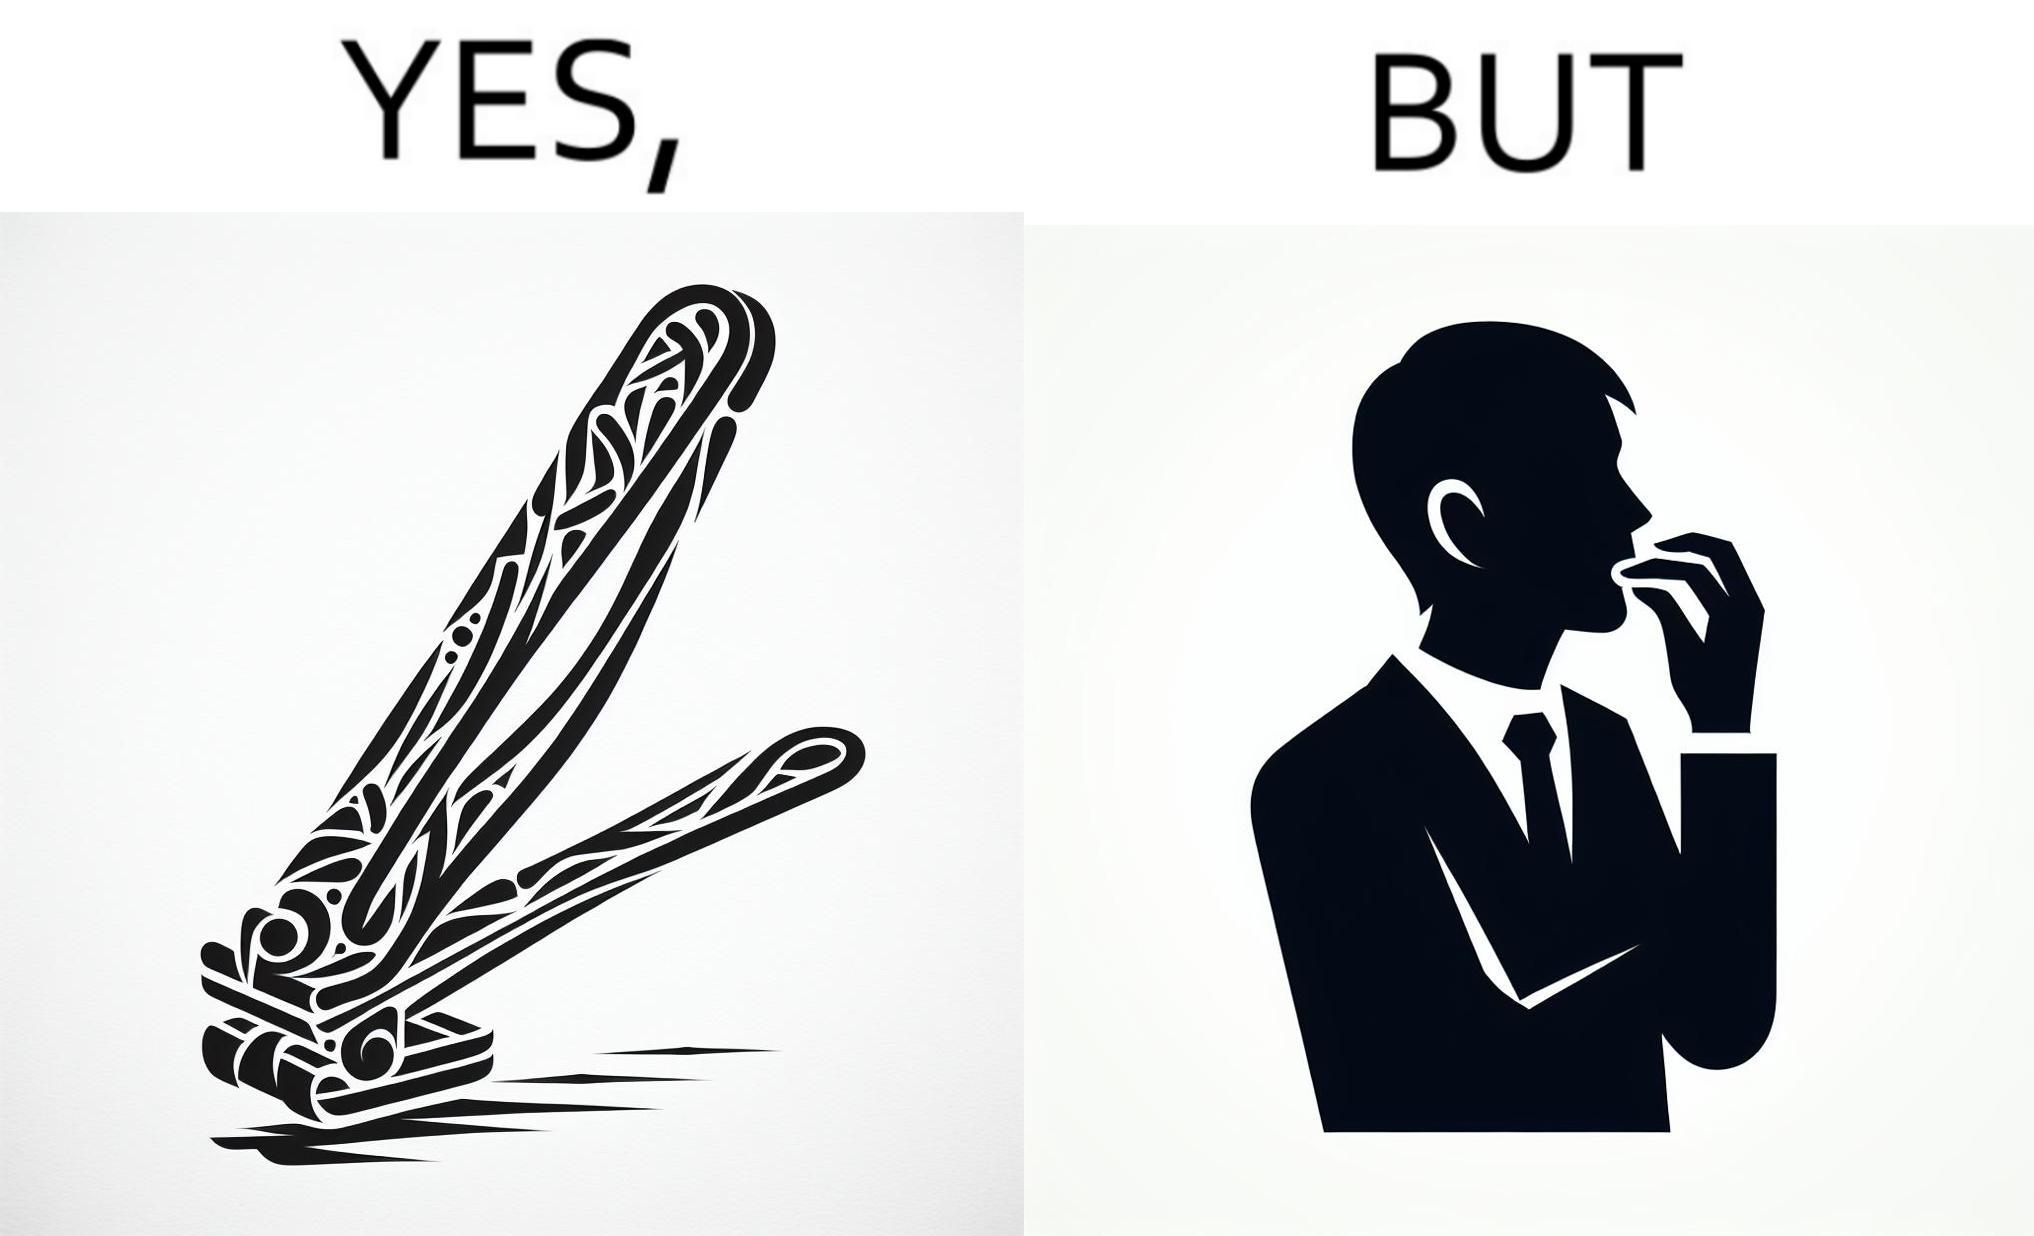Is there satirical content in this image? Yes, this image is satirical. 